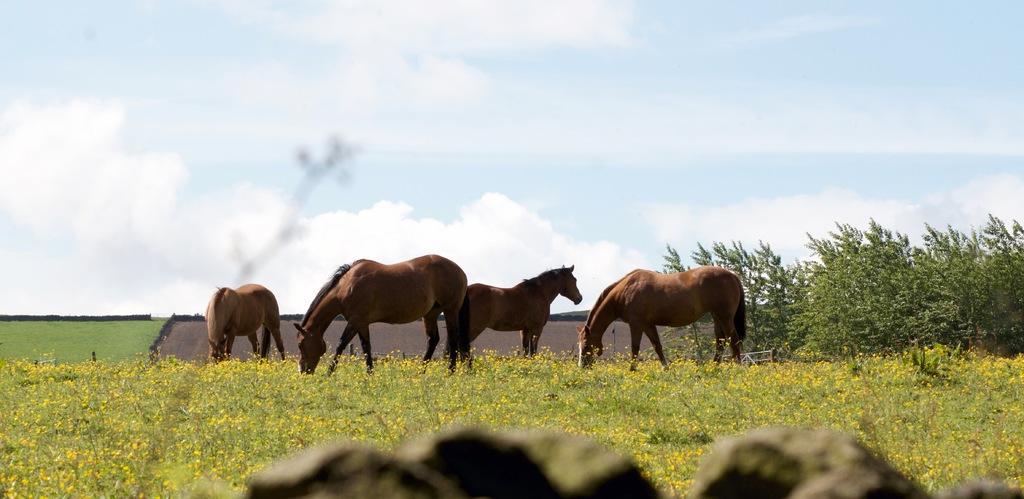Can you describe this image briefly? We can see plants, flowers, horses and trees. In the background we can see grass and sky with clouds. 